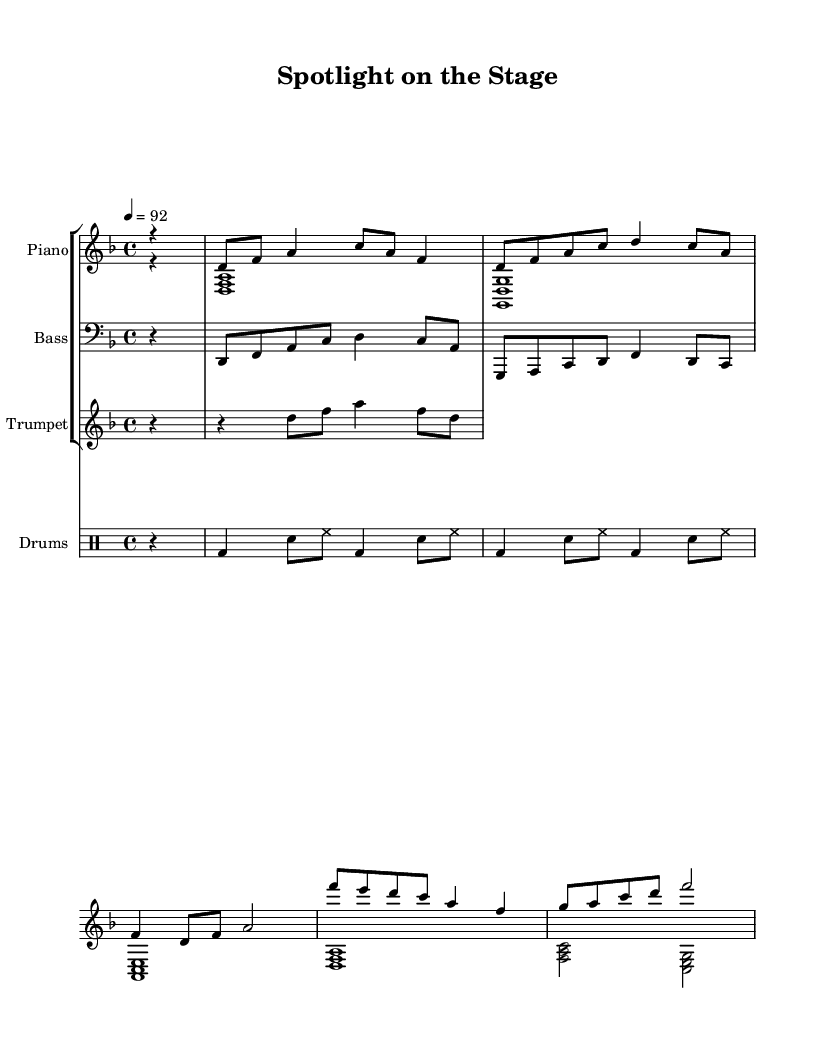What is the key signature of this music? The key signature is D minor, which has one flat (B flat). It can be found near the beginning of the sheet music, indicated by the sharps or flats shown.
Answer: D minor What is the time signature of the piece? The time signature is 4/4, shown at the beginning of the score where it indicates that there are four beats in each measure and the quarter note gets one beat.
Answer: 4/4 What is the tempo marking given in the music? The tempo marking is 92, which indicates the piece should be played at a moderate speed of 92 beats per minute. This is noted above the staff at the beginning of the score.
Answer: 92 Identify the instruments included in this piece. The instruments indicated include Piano, Bass, Trumpet, and Drums. Each instrument is shown on its own staff throughout the score.
Answer: Piano, Bass, Trumpet, Drums How many measures are in the piano right hand part? The piano right hand part contains a total of 8 measures. Each measure is defined by the vertical lines separating groups of beats within the staff.
Answer: 8 What type of musical section does the trumpet play? The trumpet plays a riff, which is a short, repeated melodic phrase often used to hook the listener. The absence of complex notes and focus on a catchy line indicates this.
Answer: Riff How is the drum pattern structured in this piece? The drum pattern is structured in a consistent rhythmic pattern of bass drum followed by snare and hi-hat. This repeating pattern can be observed clearly in the notation layout.
Answer: Consistent rhythmic pattern 